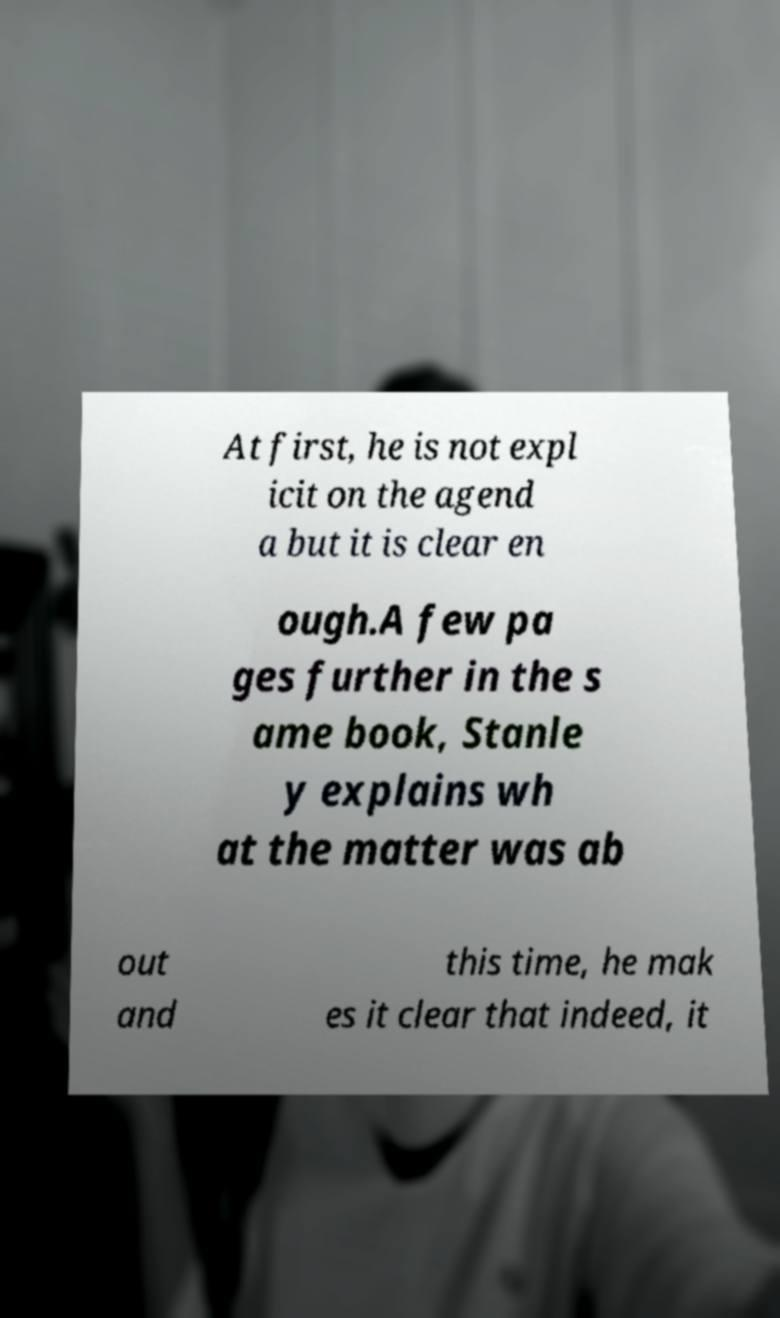Could you assist in decoding the text presented in this image and type it out clearly? At first, he is not expl icit on the agend a but it is clear en ough.A few pa ges further in the s ame book, Stanle y explains wh at the matter was ab out and this time, he mak es it clear that indeed, it 